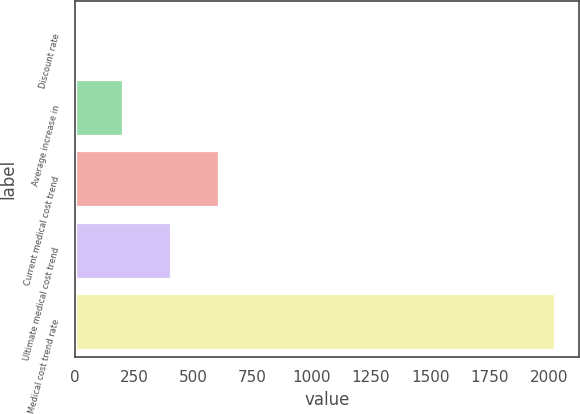Convert chart to OTSL. <chart><loc_0><loc_0><loc_500><loc_500><bar_chart><fcel>Discount rate<fcel>Average increase in<fcel>Current medical cost trend<fcel>Ultimate medical cost trend<fcel>Medical cost trend rate<nl><fcel>3.25<fcel>205.62<fcel>610.38<fcel>408<fcel>2027<nl></chart> 